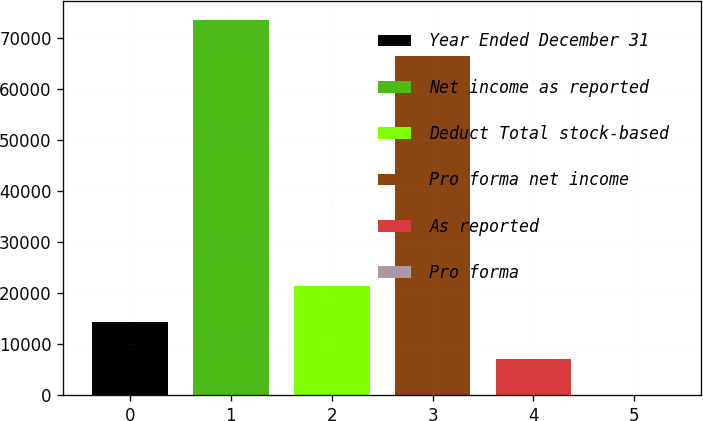Convert chart. <chart><loc_0><loc_0><loc_500><loc_500><bar_chart><fcel>Year Ended December 31<fcel>Net income as reported<fcel>Deduct Total stock-based<fcel>Pro forma net income<fcel>As reported<fcel>Pro forma<nl><fcel>14320.1<fcel>73652.4<fcel>21479.5<fcel>66493<fcel>7160.79<fcel>1.43<nl></chart> 